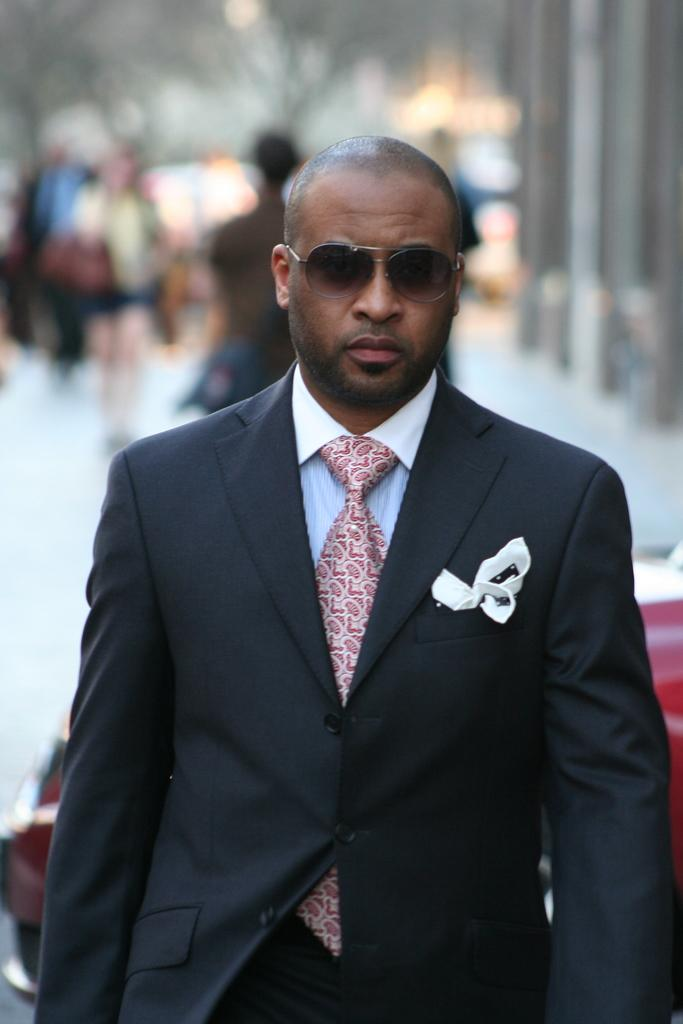Who or what is the main subject of the image? There is a person in the image. What is the person wearing on their upper body? The person is wearing a suit. What type of eyewear is the person wearing? The person is wearing goggles. What accessory is the person wearing around their neck? The person is wearing a tie. Can you describe the background of the image? The background of the image is blurred. What type of marble is visible on the floor in the image? There is no marble visible on the floor in the image; the background is blurred. What type of medical equipment can be seen in the image? There is no medical equipment or hospital setting present in the image; it features a person wearing a suit, goggles, and a tie. What type of lighting fixture is present in the image? There is no specific lighting fixture mentioned in the provided facts, and the background is blurred, so it is not possible to determine if a bulb is visible in the image. 